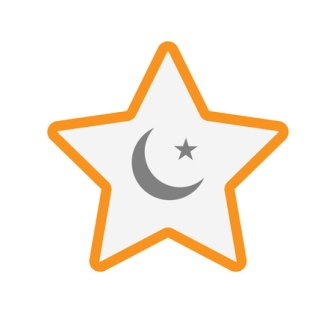What might this image symbolize in a broader cosmic context? This image could symbolize the harmony and balance of the cosmos. The prominent star represents the vast, luminous force of the universe, while the moon nestled within it signifies tranquility and reflection. The small star could symbolize a burgeoning idea or entity within this grand celestial framework, suggesting that even within great expanses, there is room for new beginnings and peaceful coexistence. Can the combination of the star and moon represent any cultural or historical themes? Yes, the combination of the star and moon is rich in cultural and historical significance. For example, the star and crescent is a symbol extensively used in Islamic art and heraldry, often representing faith and divine guidance. Historically, these celestial symbols have also been used in pagan iconography to denote celestial bodies and deities, reflecting humanity's long-standing fascination and reverence for the celestial realm. Imagine this image as the crest of an ancient civilization. What kind of civilization would that be, and what are its core values? Imagine a civilization from an ancient world that revolved around the celestial and the spiritual. Known as the Luminar, this society exists on the distant planet of Astralis. The Luminar civilization revered the cosmos as the ultimate source of wisdom and stability. Their core values included harmony with nature, balance in all things, and the pursuit of knowledge. They believed that every star and moon carried a story and a lesson. Their art and architecture deeply integrated celestial motifs to reflect their belief in cosmic connectivity and universal guidance. The star and crescent symbol was used as their crest, representing their guiding principles and the equilibrium they sought in life. 